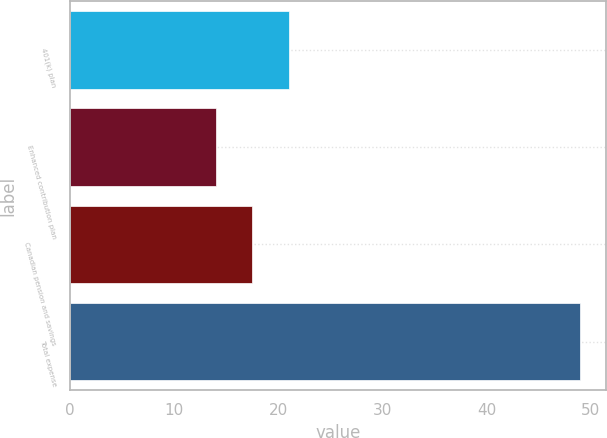Convert chart to OTSL. <chart><loc_0><loc_0><loc_500><loc_500><bar_chart><fcel>401(k) plan<fcel>Enhanced contribution plan<fcel>Canadian pension and savings<fcel>Total expense<nl><fcel>21<fcel>14<fcel>17.5<fcel>49<nl></chart> 